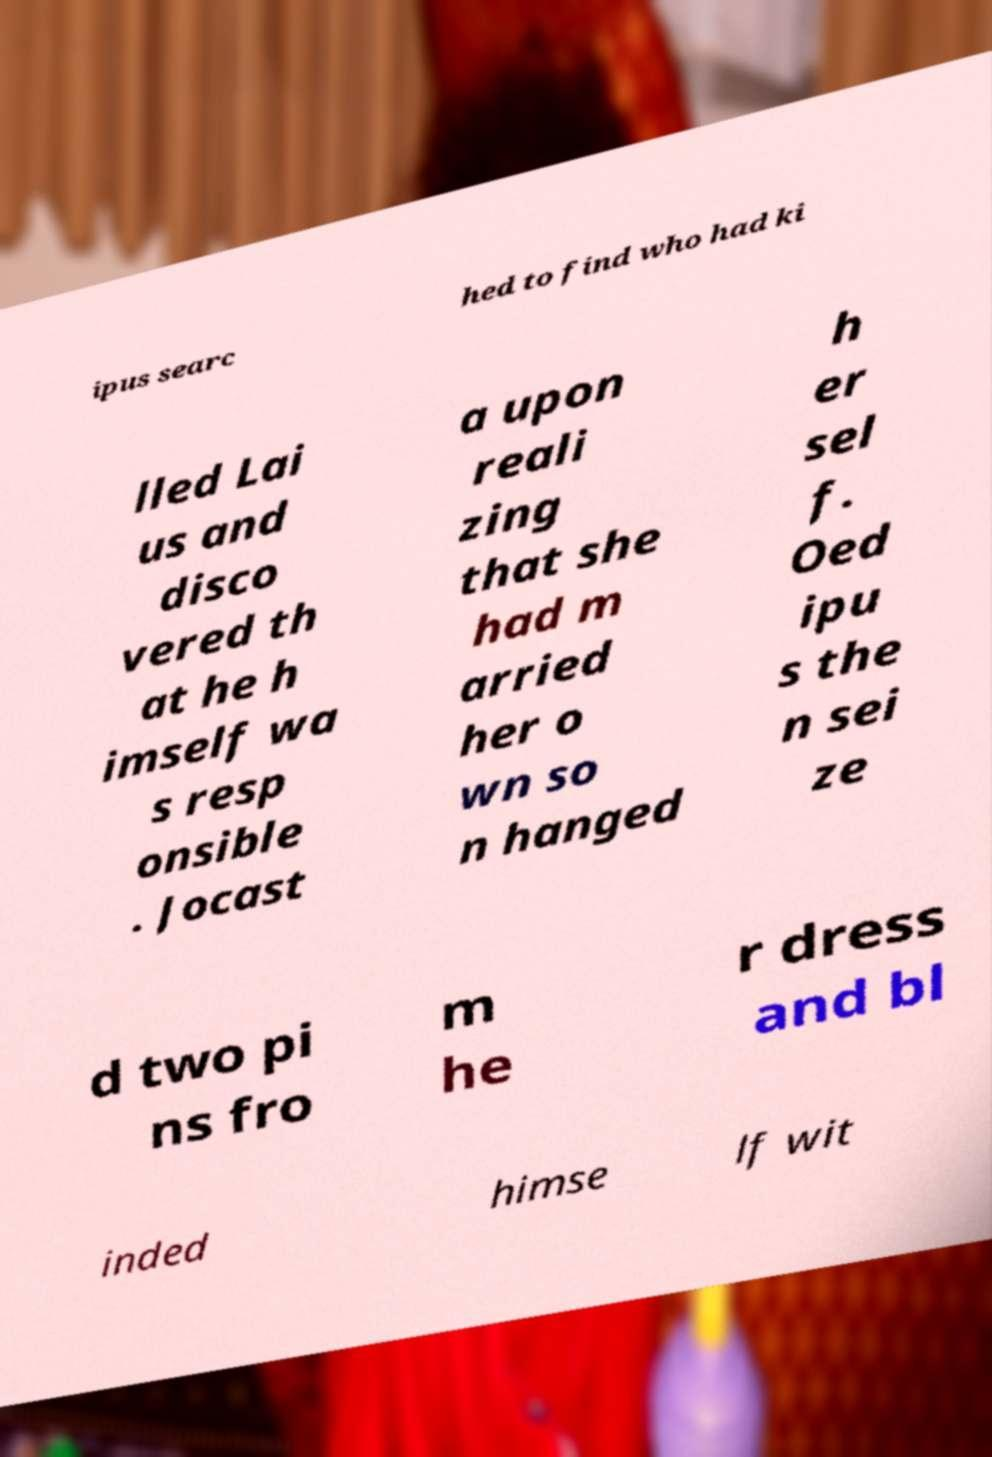I need the written content from this picture converted into text. Can you do that? ipus searc hed to find who had ki lled Lai us and disco vered th at he h imself wa s resp onsible . Jocast a upon reali zing that she had m arried her o wn so n hanged h er sel f. Oed ipu s the n sei ze d two pi ns fro m he r dress and bl inded himse lf wit 